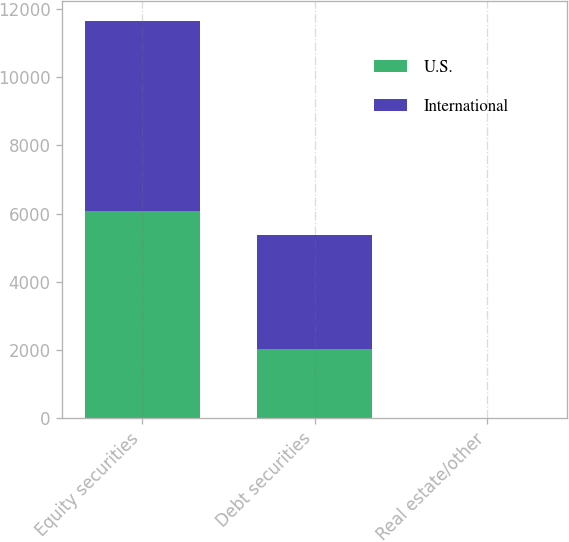<chart> <loc_0><loc_0><loc_500><loc_500><stacked_bar_chart><ecel><fcel>Equity securities<fcel>Debt securities<fcel>Real estate/other<nl><fcel>U.S.<fcel>6080<fcel>2030<fcel>10<nl><fcel>International<fcel>5566<fcel>3344<fcel>2<nl></chart> 